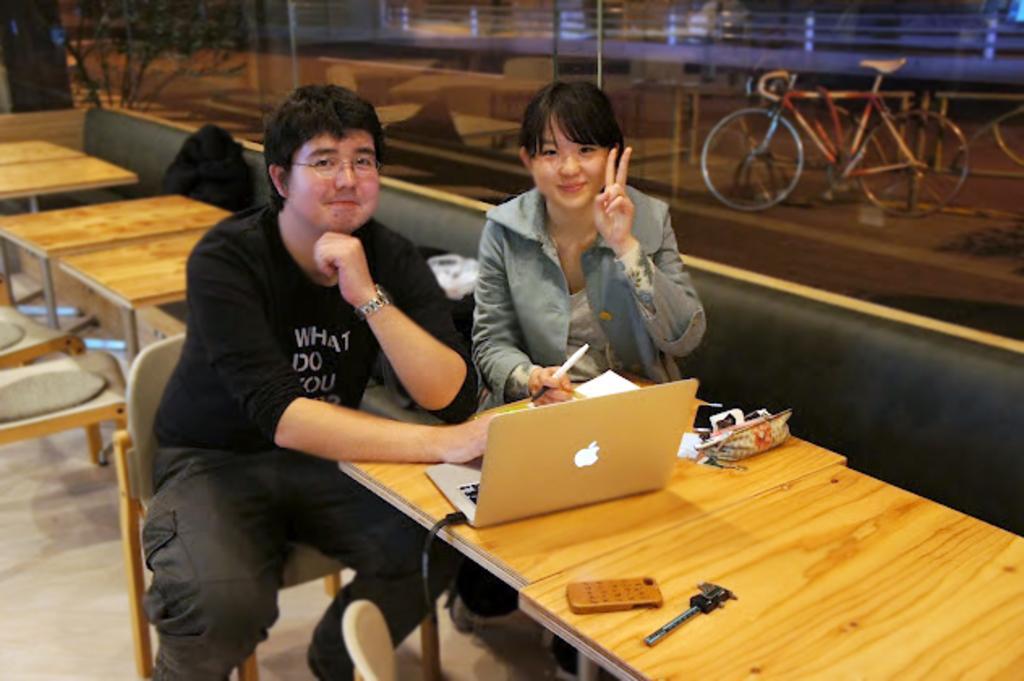Describe this image in one or two sentences. As we can see in the image there are two people sitting in the front on chairs. On table there is a laptop and a pouch. In the background there is a bicycle, buildings and a tree. 